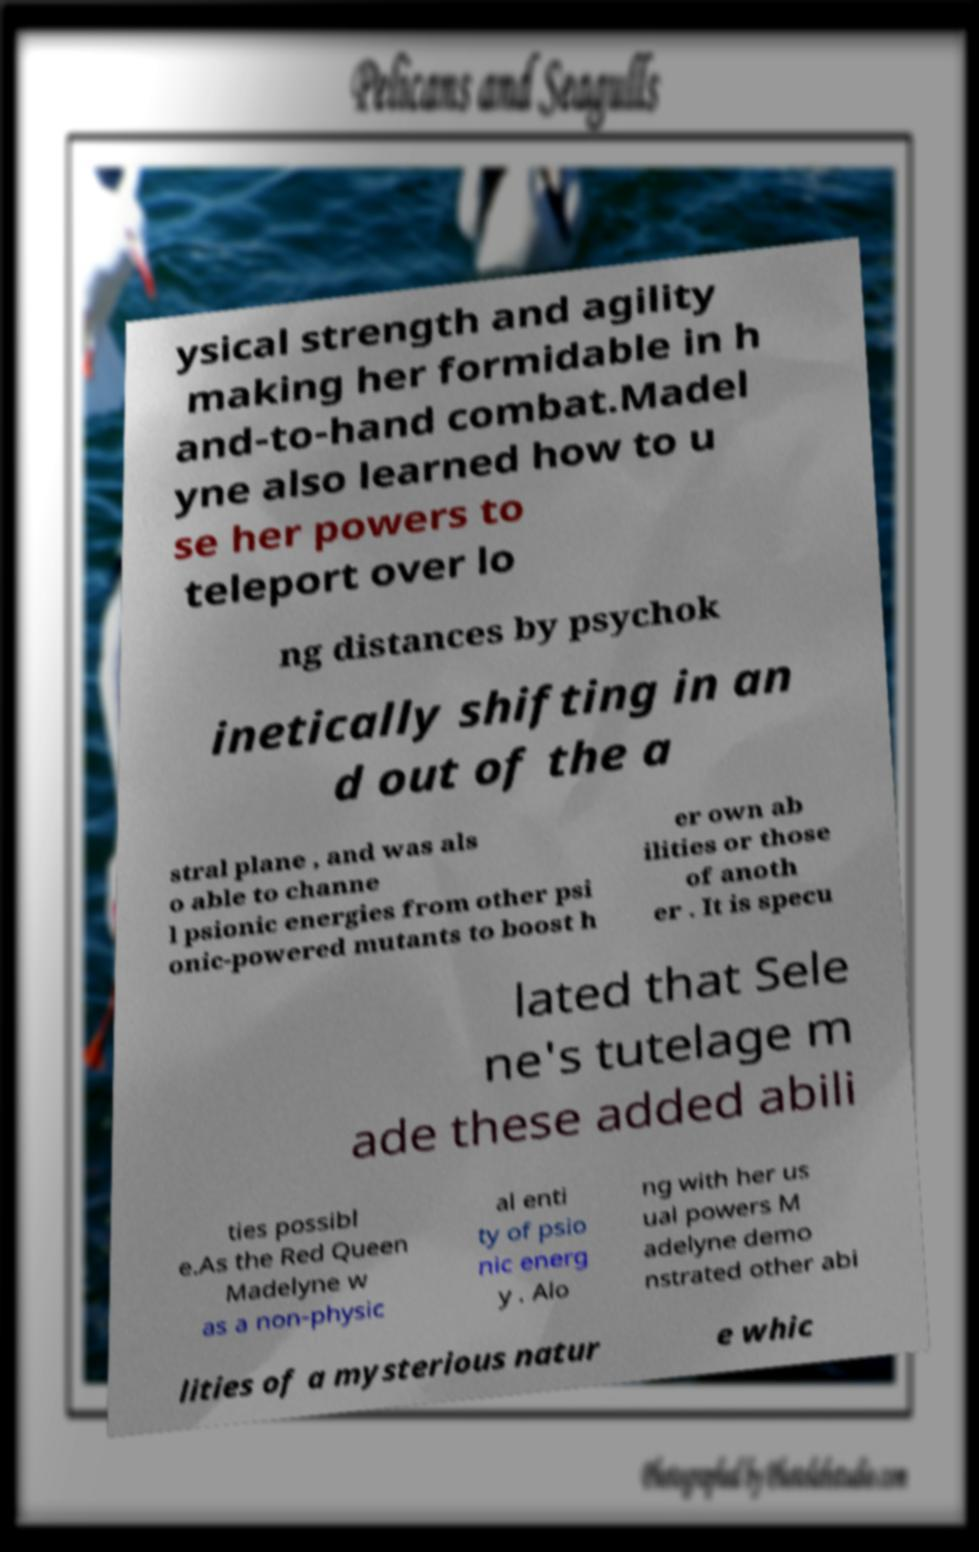Could you assist in decoding the text presented in this image and type it out clearly? ysical strength and agility making her formidable in h and-to-hand combat.Madel yne also learned how to u se her powers to teleport over lo ng distances by psychok inetically shifting in an d out of the a stral plane , and was als o able to channe l psionic energies from other psi onic-powered mutants to boost h er own ab ilities or those of anoth er . It is specu lated that Sele ne's tutelage m ade these added abili ties possibl e.As the Red Queen Madelyne w as a non-physic al enti ty of psio nic energ y . Alo ng with her us ual powers M adelyne demo nstrated other abi lities of a mysterious natur e whic 